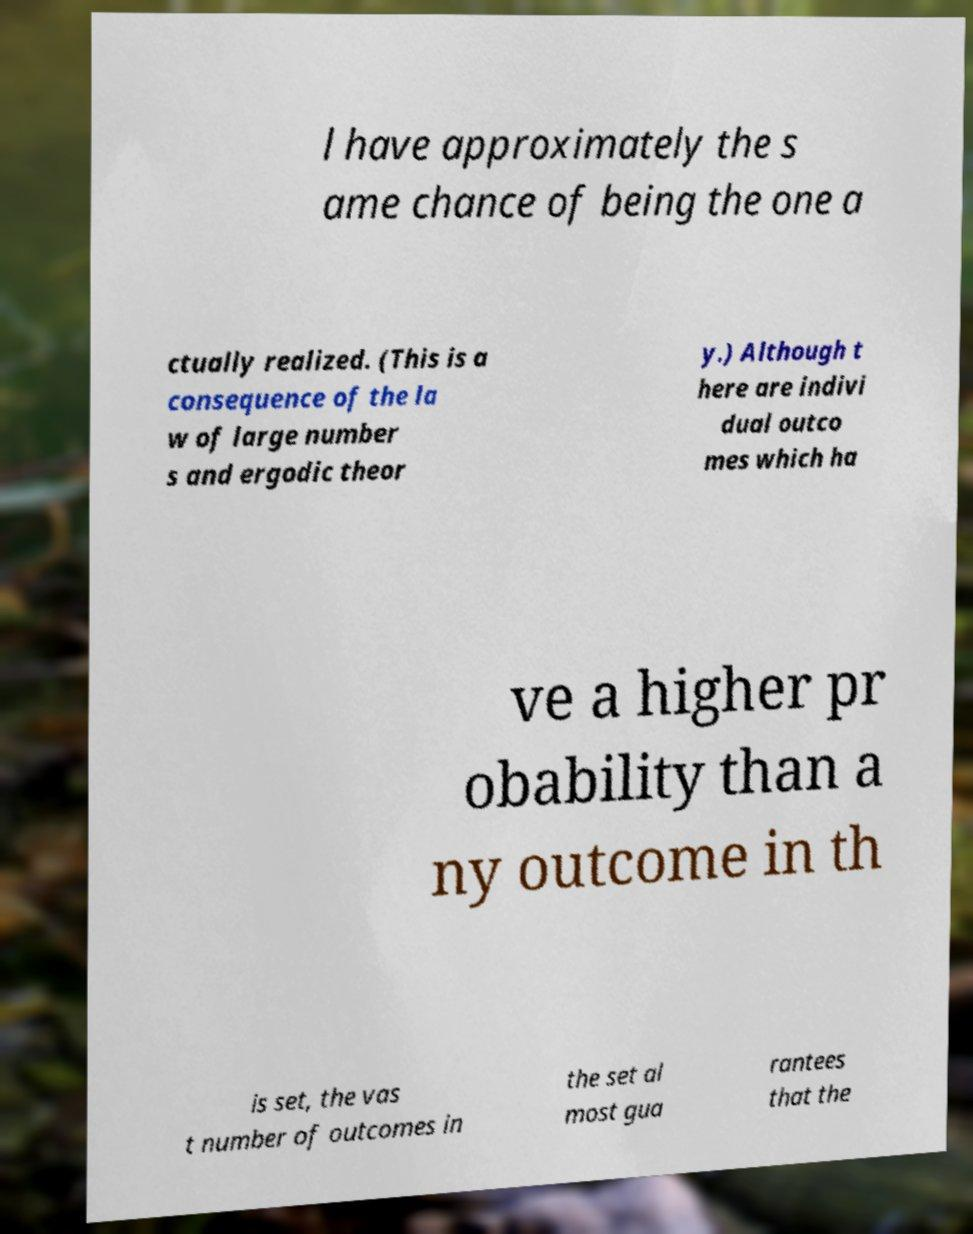What messages or text are displayed in this image? I need them in a readable, typed format. l have approximately the s ame chance of being the one a ctually realized. (This is a consequence of the la w of large number s and ergodic theor y.) Although t here are indivi dual outco mes which ha ve a higher pr obability than a ny outcome in th is set, the vas t number of outcomes in the set al most gua rantees that the 